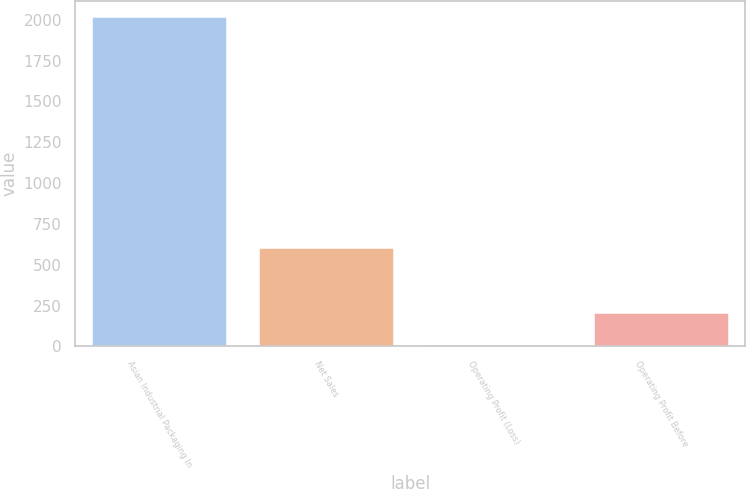Convert chart to OTSL. <chart><loc_0><loc_0><loc_500><loc_500><bar_chart><fcel>Asian Industrial Packaging In<fcel>Net Sales<fcel>Operating Profit (Loss)<fcel>Operating Profit Before<nl><fcel>2015<fcel>601<fcel>6<fcel>206.9<nl></chart> 